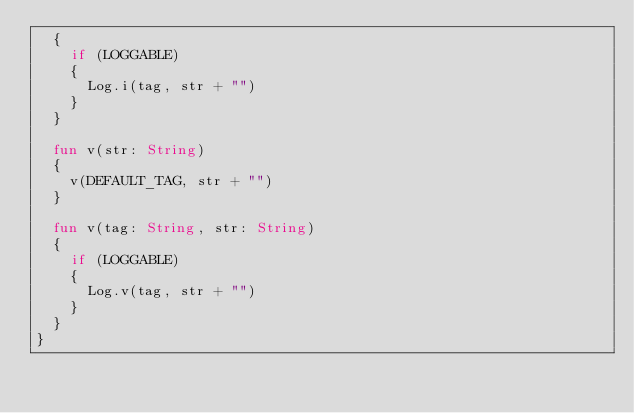Convert code to text. <code><loc_0><loc_0><loc_500><loc_500><_Kotlin_>	{
		if (LOGGABLE)
		{
			Log.i(tag, str + "")
		}
	}

	fun v(str: String)
	{
		v(DEFAULT_TAG, str + "")
	}

	fun v(tag: String, str: String)
	{
		if (LOGGABLE)
		{
			Log.v(tag, str + "")
		}
	}
}
</code> 